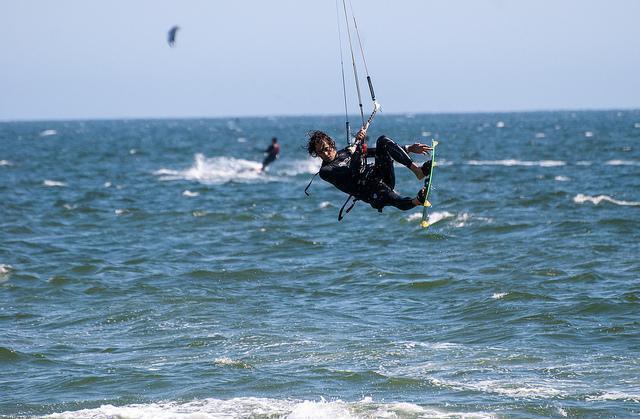What is above this person?
Select the accurate answer and provide explanation: 'Answer: answer
Rationale: rationale.'
Options: Drone, cloud, parasail, crane. Answer: parasail.
Rationale: Based on the equipment the person is using and the harness they are strapped into, the object above them at the other end of the straps would be answer a. 